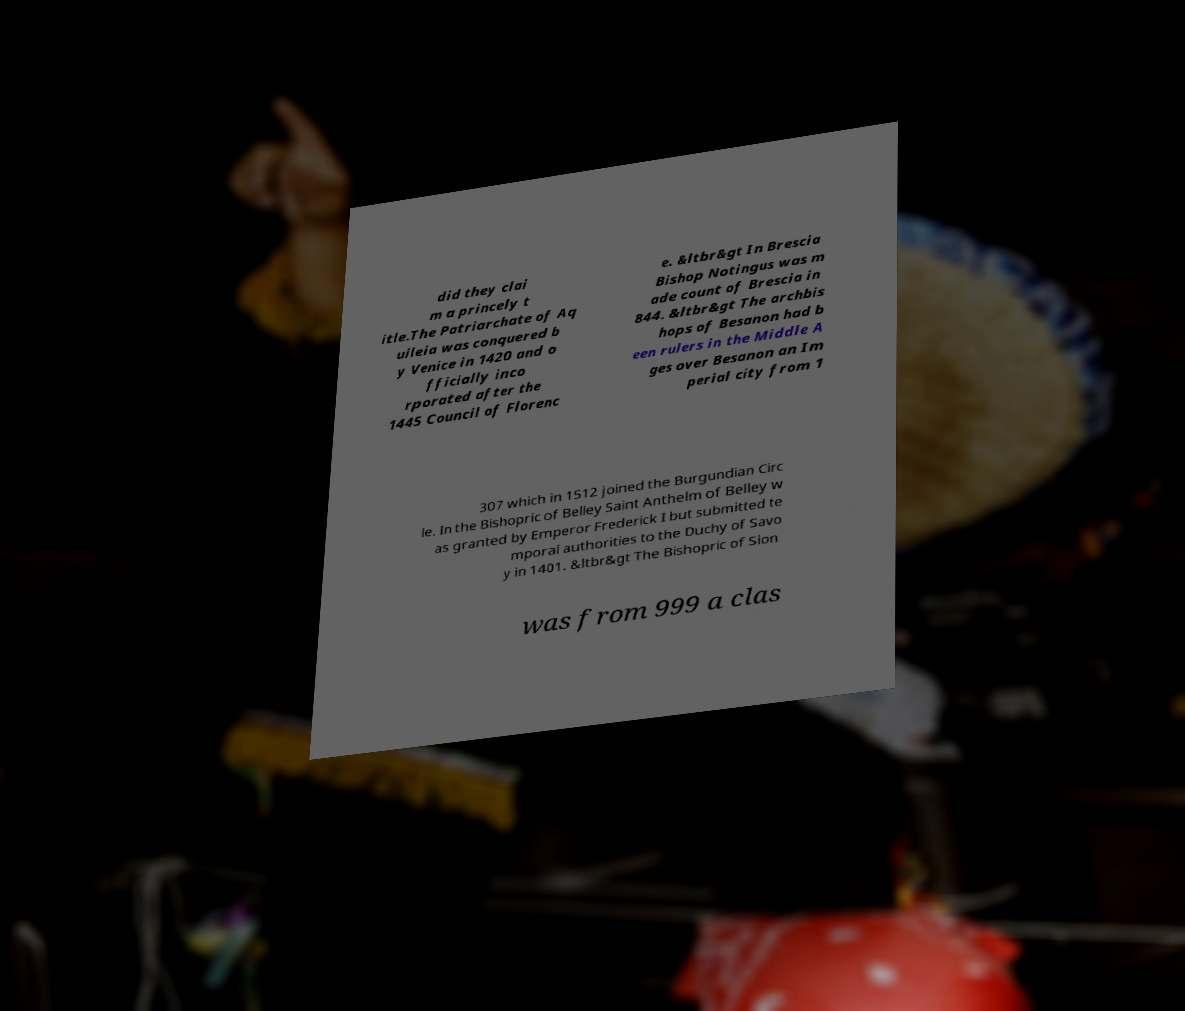I need the written content from this picture converted into text. Can you do that? did they clai m a princely t itle.The Patriarchate of Aq uileia was conquered b y Venice in 1420 and o fficially inco rporated after the 1445 Council of Florenc e. &ltbr&gt In Brescia Bishop Notingus was m ade count of Brescia in 844. &ltbr&gt The archbis hops of Besanon had b een rulers in the Middle A ges over Besanon an Im perial city from 1 307 which in 1512 joined the Burgundian Circ le. In the Bishopric of Belley Saint Anthelm of Belley w as granted by Emperor Frederick I but submitted te mporal authorities to the Duchy of Savo y in 1401. &ltbr&gt The Bishopric of Sion was from 999 a clas 